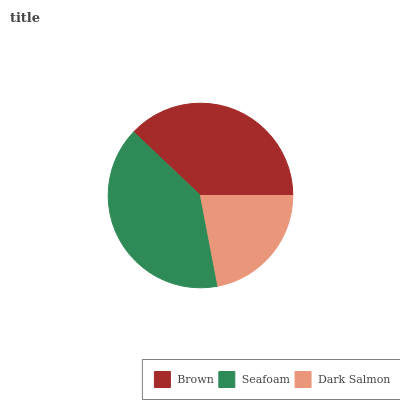Is Dark Salmon the minimum?
Answer yes or no. Yes. Is Seafoam the maximum?
Answer yes or no. Yes. Is Seafoam the minimum?
Answer yes or no. No. Is Dark Salmon the maximum?
Answer yes or no. No. Is Seafoam greater than Dark Salmon?
Answer yes or no. Yes. Is Dark Salmon less than Seafoam?
Answer yes or no. Yes. Is Dark Salmon greater than Seafoam?
Answer yes or no. No. Is Seafoam less than Dark Salmon?
Answer yes or no. No. Is Brown the high median?
Answer yes or no. Yes. Is Brown the low median?
Answer yes or no. Yes. Is Seafoam the high median?
Answer yes or no. No. Is Seafoam the low median?
Answer yes or no. No. 